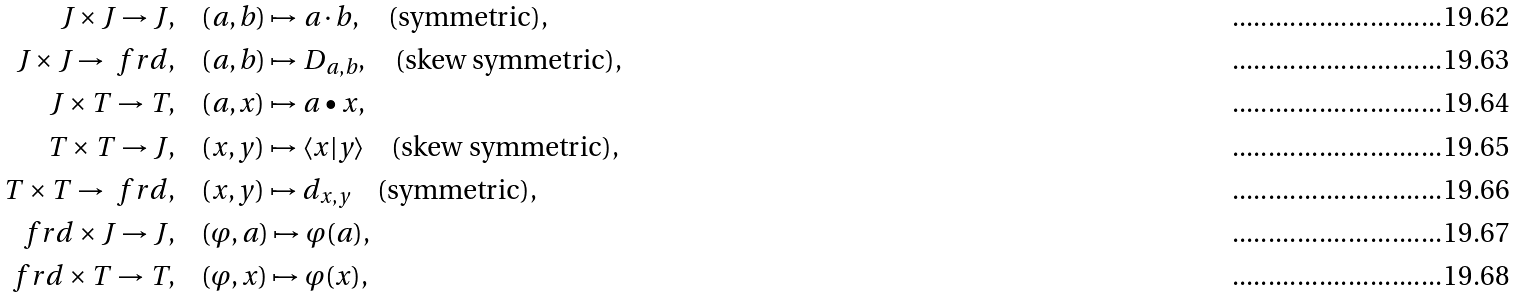Convert formula to latex. <formula><loc_0><loc_0><loc_500><loc_500>J \times J \rightarrow J , & \quad ( a , b ) \mapsto a \cdot b , \quad \text {(symmetric),} \\ J \times J \rightarrow \ f r d , & \quad ( a , b ) \mapsto D _ { a , b } , \quad \text {(skew symmetric),} \\ J \times T \rightarrow T , & \quad ( a , x ) \mapsto a \bullet x , \\ T \times T \rightarrow J , & \quad ( x , y ) \mapsto \langle x | y \rangle \quad \text {(skew symmetric),} \\ T \times T \rightarrow \ f r d , & \quad ( x , y ) \mapsto d _ { x , y } \quad \text {(symmetric),} \\ \ f r d \times J \rightarrow J , & \quad ( \varphi , a ) \mapsto \varphi ( a ) , \\ \ f r d \times T \rightarrow T , & \quad ( \varphi , x ) \mapsto \varphi ( x ) ,</formula> 